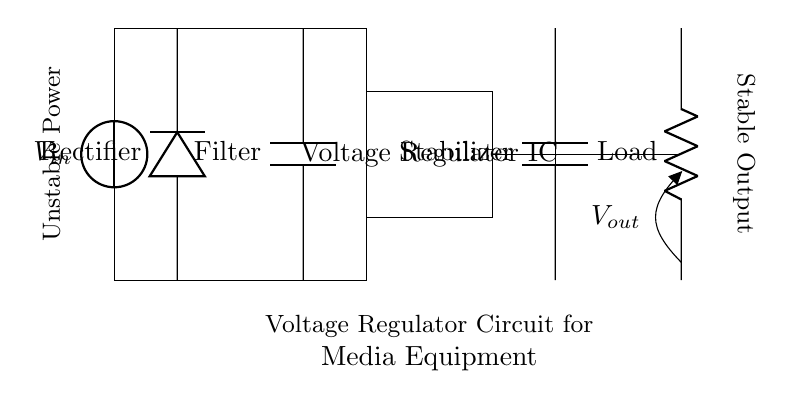What is the primary function of this circuit? The primary function is to stabilize the voltage for media equipment. This can be inferred from the labeling in the diagram and the presence of a voltage regulator.
Answer: Stabilize voltage What type of component is the voltage regulator labeled in the circuit diagram? The component labeled is a Voltage Regulator IC, which indicates that it's an integrated circuit designed to maintain a steady output voltage.
Answer: Integrated circuit What is the role of the capacitor in this circuit? The capacitor is labeled as a Filter, which suggests its role in smoothing out voltage fluctuations after rectification, ensuring a more stable DC voltage.
Answer: Smoothing How many capacitors are present in the circuit, and what are their functions? There are two capacitors: one acts as a filter after rectification, while the other is a stabilizer to maintain voltage stability at the output.
Answer: Two capacitors What voltage is expected at the output labeled V out? The specific output voltage is not detailed in the circuit; however, it is designed to be stable and suitable for powering media equipment, often around 5V in typical applications.
Answer: Stable voltage What happens to the unstable power entering the circuit? The unstable power is rectified and filtered by the components, especially the diode and capacitors, before reaching the voltage regulator for stabilization.
Answer: Rectified and filtered What is the purpose of the load resistor in the circuit? The load resistor is connected to the output, simulating the actual media equipment that the voltage regulator powers, ensuring the circuit operates under load conditions.
Answer: Simulate load 